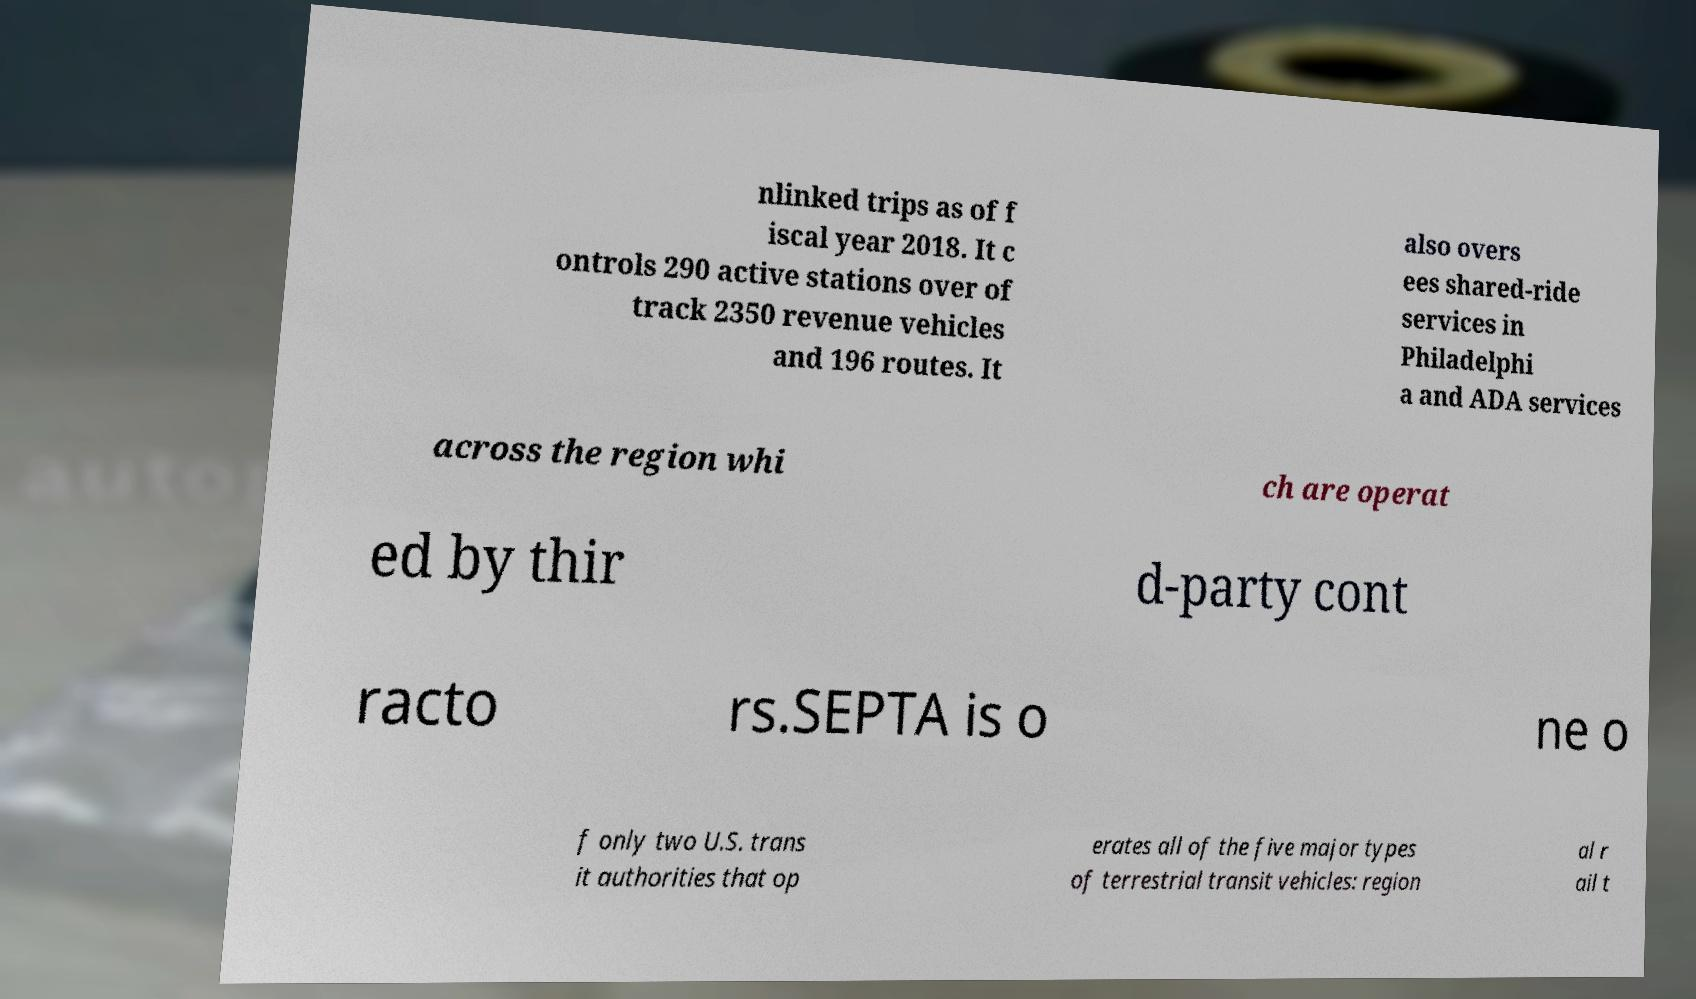Could you extract and type out the text from this image? nlinked trips as of f iscal year 2018. It c ontrols 290 active stations over of track 2350 revenue vehicles and 196 routes. It also overs ees shared-ride services in Philadelphi a and ADA services across the region whi ch are operat ed by thir d-party cont racto rs.SEPTA is o ne o f only two U.S. trans it authorities that op erates all of the five major types of terrestrial transit vehicles: region al r ail t 